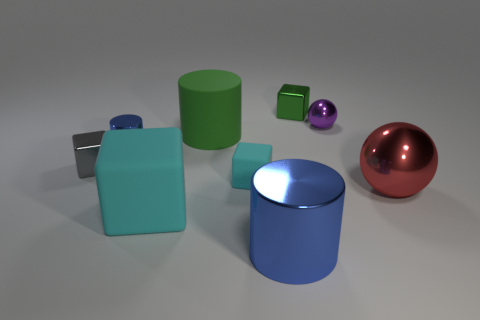Add 1 large things. How many objects exist? 10 Subtract all cylinders. How many objects are left? 6 Subtract all blue shiny cylinders. Subtract all big cylinders. How many objects are left? 5 Add 8 tiny cyan objects. How many tiny cyan objects are left? 9 Add 3 gray blocks. How many gray blocks exist? 4 Subtract 0 brown blocks. How many objects are left? 9 